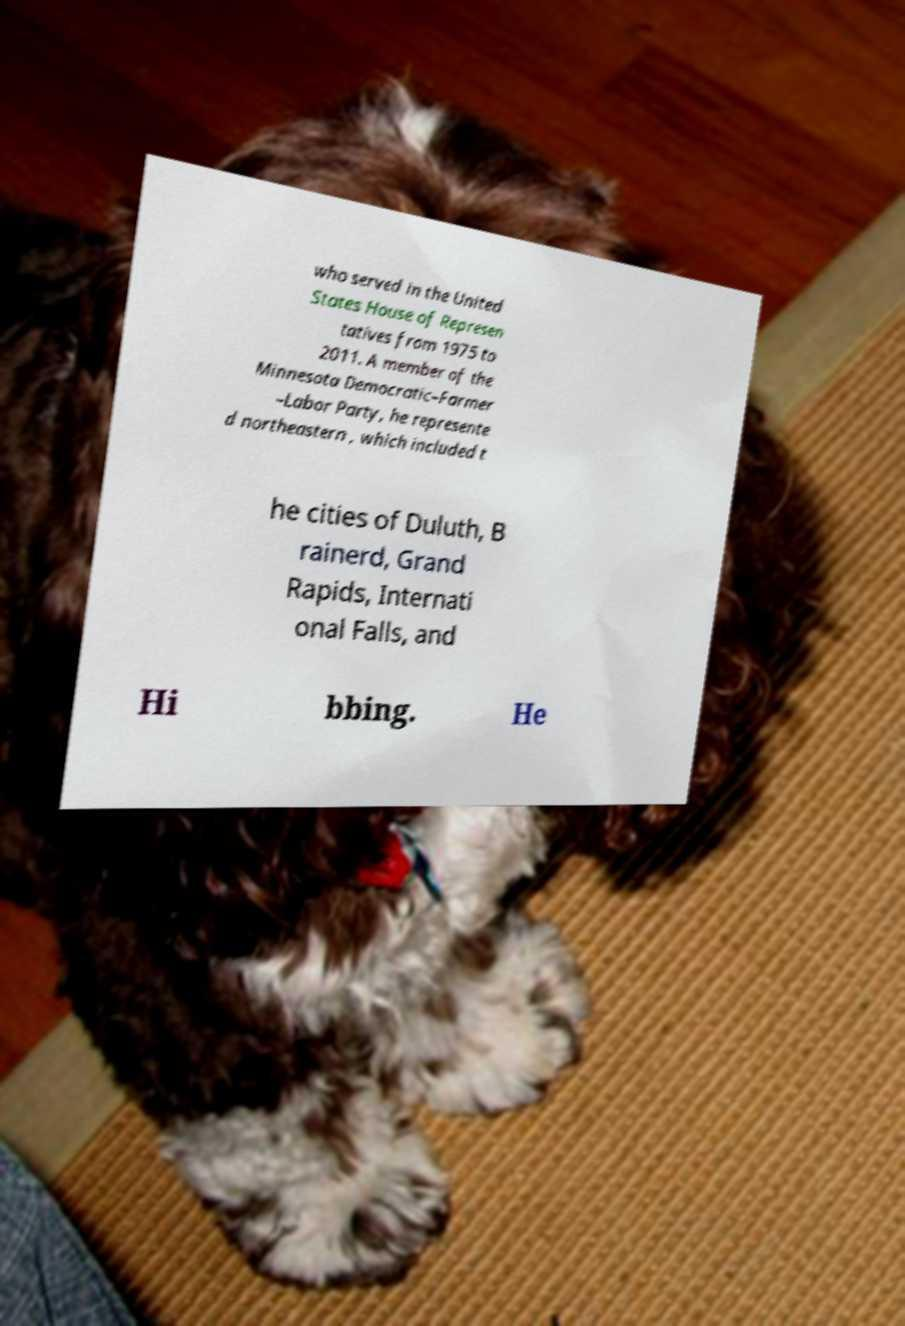Could you extract and type out the text from this image? who served in the United States House of Represen tatives from 1975 to 2011. A member of the Minnesota Democratic–Farmer –Labor Party, he represente d northeastern , which included t he cities of Duluth, B rainerd, Grand Rapids, Internati onal Falls, and Hi bbing. He 